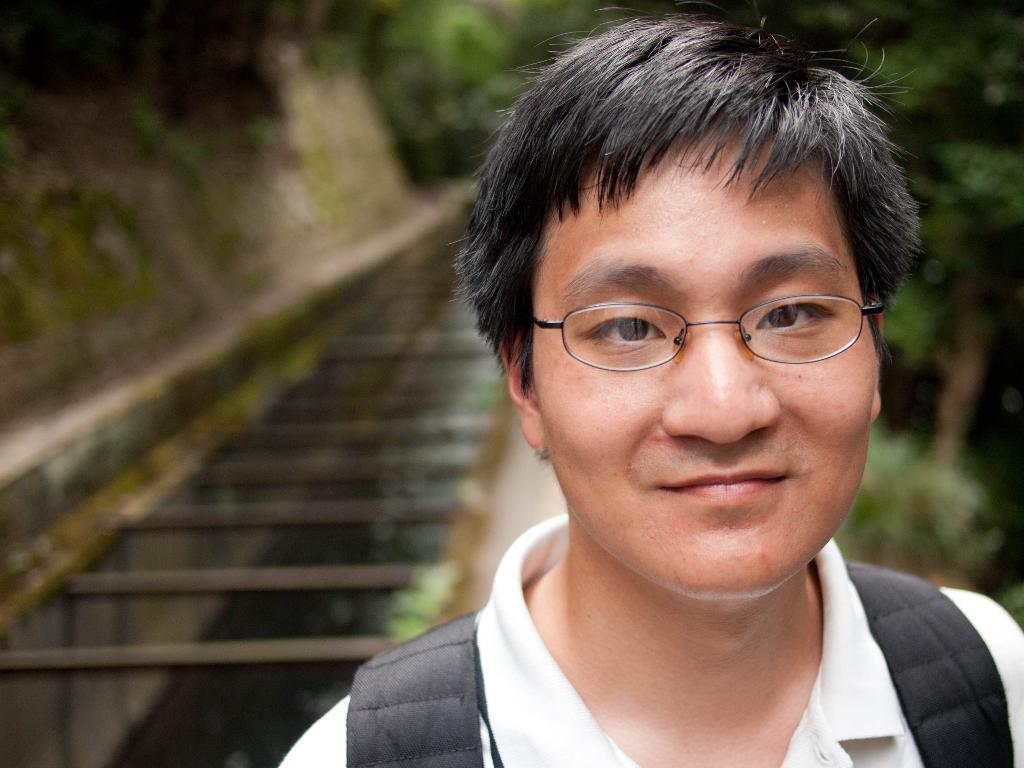Who is present in the image? There is a man in the image. What is the man wearing? The man is wearing a white t-shirt. What is the man carrying in the image? The man is carrying a black bag. What can be seen in the background of the image? The background of the image is black. What type of animal is sitting on the cloth in the image? There is no animal or cloth present in the image. What color is the hydrant in the image? There is no hydrant present in the image. 